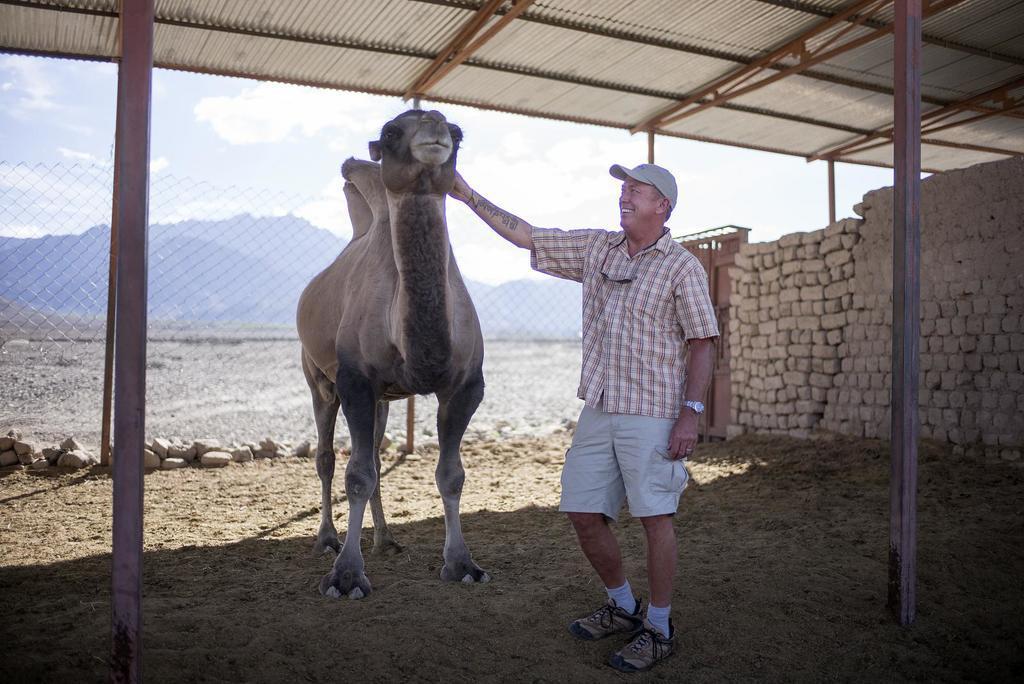Describe this image in one or two sentences. In this image there is a person touching the camel. At the bottom of the image there is a sand. There is a shed. On the right side of the image there are bricks. There is a door. In the background of the image there is a fence. There are mountains and sky. 